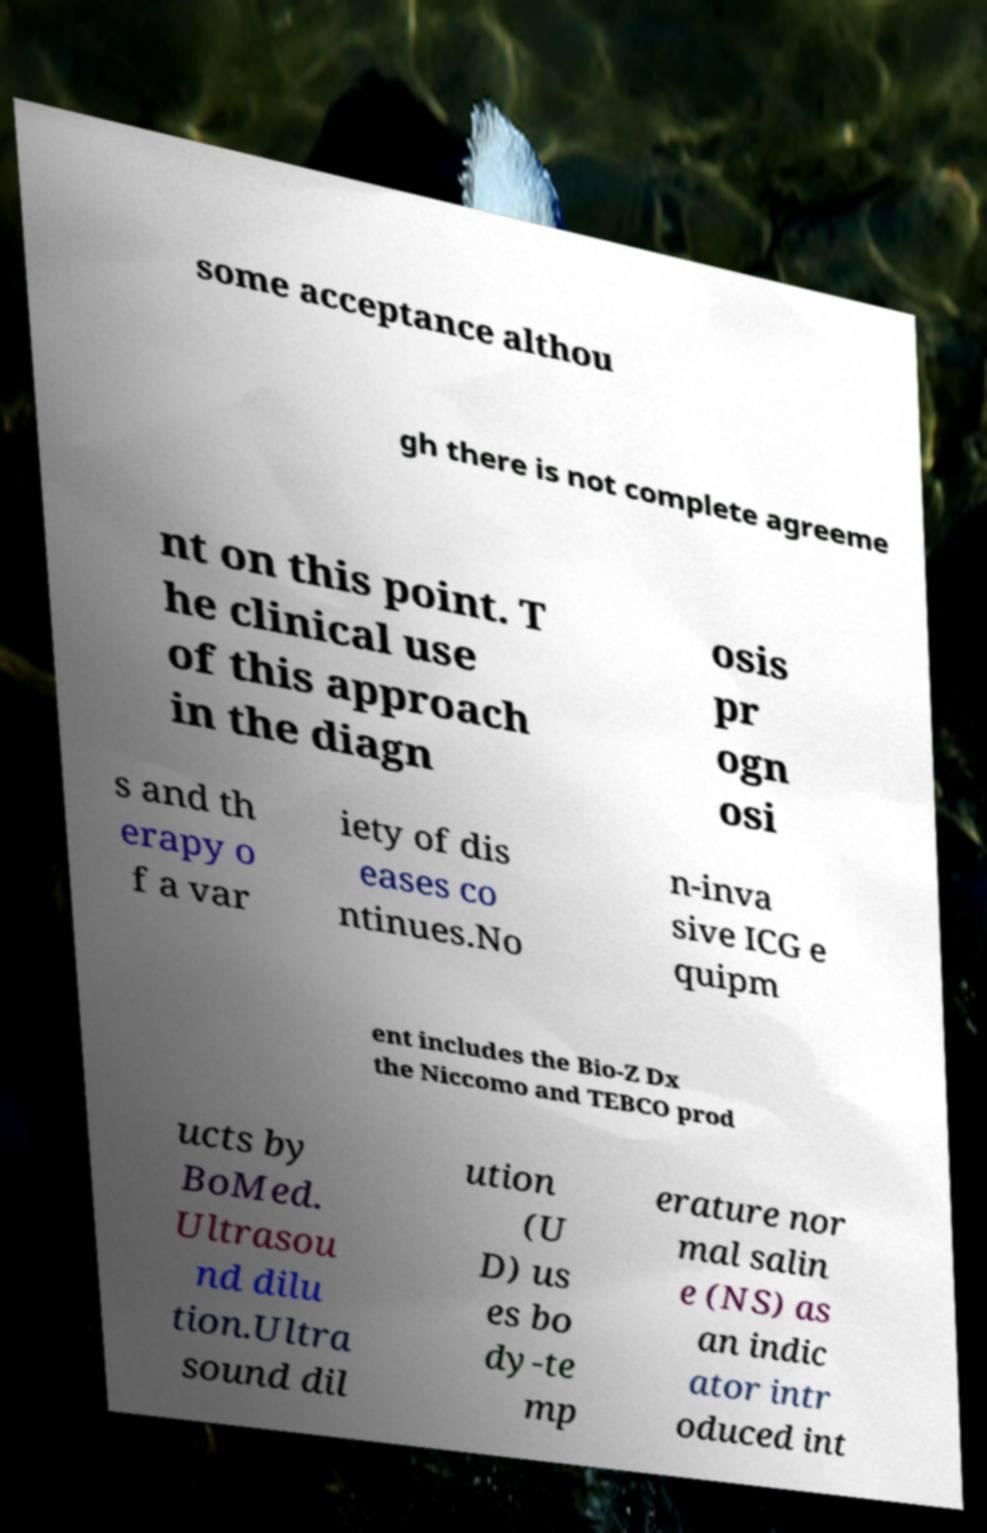Can you read and provide the text displayed in the image?This photo seems to have some interesting text. Can you extract and type it out for me? some acceptance althou gh there is not complete agreeme nt on this point. T he clinical use of this approach in the diagn osis pr ogn osi s and th erapy o f a var iety of dis eases co ntinues.No n-inva sive ICG e quipm ent includes the Bio-Z Dx the Niccomo and TEBCO prod ucts by BoMed. Ultrasou nd dilu tion.Ultra sound dil ution (U D) us es bo dy-te mp erature nor mal salin e (NS) as an indic ator intr oduced int 